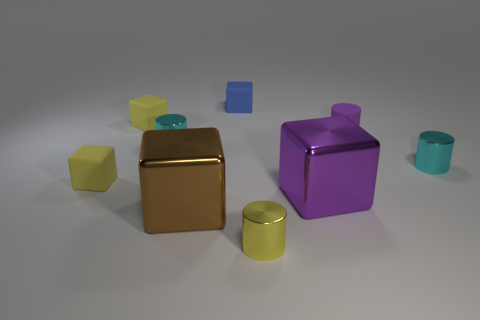Subtract all brown blocks. How many blocks are left? 4 Subtract all red cylinders. How many yellow blocks are left? 2 Add 1 green cubes. How many objects exist? 10 Subtract 2 cubes. How many cubes are left? 3 Subtract all yellow blocks. How many blocks are left? 3 Subtract all cubes. How many objects are left? 4 Add 5 tiny yellow things. How many tiny yellow things are left? 8 Add 7 big blue cylinders. How many big blue cylinders exist? 7 Subtract 1 purple blocks. How many objects are left? 8 Subtract all brown cylinders. Subtract all cyan blocks. How many cylinders are left? 4 